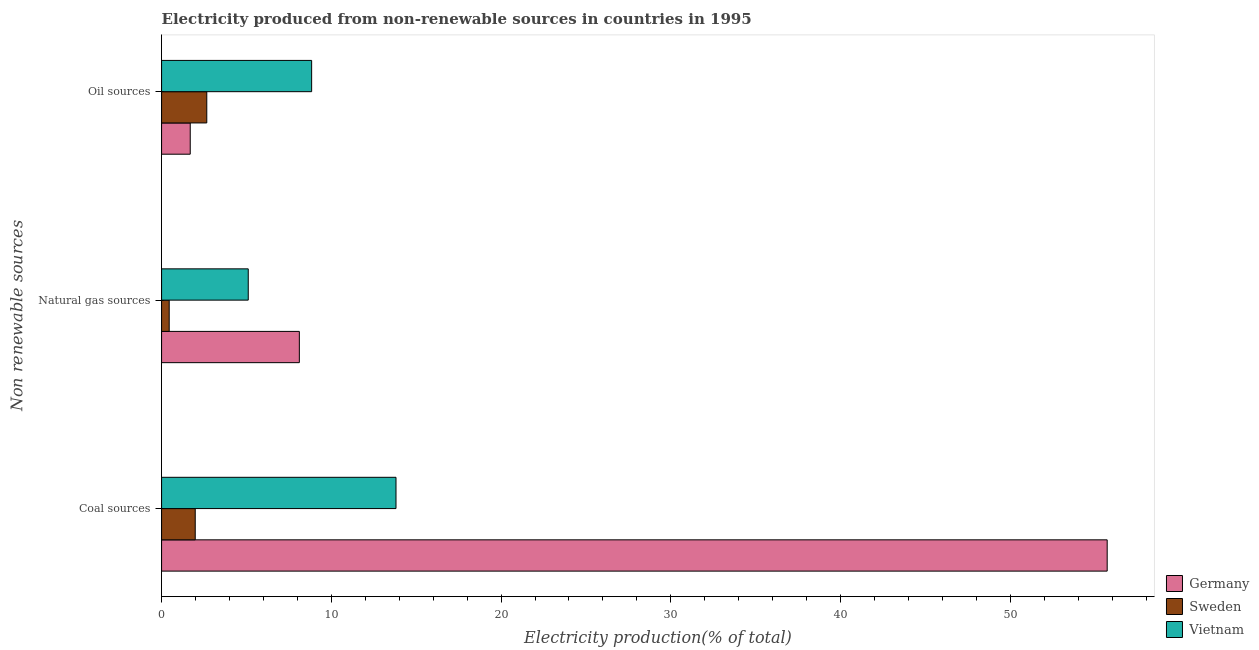How many different coloured bars are there?
Provide a short and direct response. 3. How many groups of bars are there?
Offer a terse response. 3. Are the number of bars per tick equal to the number of legend labels?
Give a very brief answer. Yes. What is the label of the 2nd group of bars from the top?
Offer a terse response. Natural gas sources. What is the percentage of electricity produced by natural gas in Germany?
Provide a short and direct response. 8.12. Across all countries, what is the maximum percentage of electricity produced by coal?
Your answer should be compact. 55.71. Across all countries, what is the minimum percentage of electricity produced by coal?
Your answer should be compact. 1.98. In which country was the percentage of electricity produced by natural gas minimum?
Make the answer very short. Sweden. What is the total percentage of electricity produced by natural gas in the graph?
Your answer should be very brief. 13.67. What is the difference between the percentage of electricity produced by oil sources in Sweden and that in Vietnam?
Ensure brevity in your answer.  -6.18. What is the difference between the percentage of electricity produced by natural gas in Germany and the percentage of electricity produced by oil sources in Sweden?
Your response must be concise. 5.45. What is the average percentage of electricity produced by natural gas per country?
Provide a short and direct response. 4.56. What is the difference between the percentage of electricity produced by coal and percentage of electricity produced by natural gas in Sweden?
Give a very brief answer. 1.53. In how many countries, is the percentage of electricity produced by coal greater than 4 %?
Give a very brief answer. 2. What is the ratio of the percentage of electricity produced by natural gas in Vietnam to that in Germany?
Your response must be concise. 0.63. Is the percentage of electricity produced by coal in Germany less than that in Vietnam?
Make the answer very short. No. Is the difference between the percentage of electricity produced by coal in Sweden and Germany greater than the difference between the percentage of electricity produced by oil sources in Sweden and Germany?
Provide a succinct answer. No. What is the difference between the highest and the second highest percentage of electricity produced by coal?
Your answer should be compact. 41.9. What is the difference between the highest and the lowest percentage of electricity produced by coal?
Your response must be concise. 53.72. Is it the case that in every country, the sum of the percentage of electricity produced by coal and percentage of electricity produced by natural gas is greater than the percentage of electricity produced by oil sources?
Your answer should be very brief. No. How many bars are there?
Your response must be concise. 9. Are all the bars in the graph horizontal?
Your response must be concise. Yes. How many countries are there in the graph?
Give a very brief answer. 3. Are the values on the major ticks of X-axis written in scientific E-notation?
Keep it short and to the point. No. Does the graph contain grids?
Give a very brief answer. No. Where does the legend appear in the graph?
Make the answer very short. Bottom right. How are the legend labels stacked?
Your response must be concise. Vertical. What is the title of the graph?
Your answer should be compact. Electricity produced from non-renewable sources in countries in 1995. What is the label or title of the X-axis?
Make the answer very short. Electricity production(% of total). What is the label or title of the Y-axis?
Give a very brief answer. Non renewable sources. What is the Electricity production(% of total) of Germany in Coal sources?
Ensure brevity in your answer.  55.71. What is the Electricity production(% of total) in Sweden in Coal sources?
Your answer should be compact. 1.98. What is the Electricity production(% of total) in Vietnam in Coal sources?
Keep it short and to the point. 13.81. What is the Electricity production(% of total) of Germany in Natural gas sources?
Your answer should be very brief. 8.12. What is the Electricity production(% of total) in Sweden in Natural gas sources?
Keep it short and to the point. 0.45. What is the Electricity production(% of total) in Vietnam in Natural gas sources?
Offer a very short reply. 5.11. What is the Electricity production(% of total) of Germany in Oil sources?
Provide a succinct answer. 1.69. What is the Electricity production(% of total) in Sweden in Oil sources?
Keep it short and to the point. 2.66. What is the Electricity production(% of total) of Vietnam in Oil sources?
Provide a succinct answer. 8.84. Across all Non renewable sources, what is the maximum Electricity production(% of total) of Germany?
Provide a succinct answer. 55.71. Across all Non renewable sources, what is the maximum Electricity production(% of total) of Sweden?
Keep it short and to the point. 2.66. Across all Non renewable sources, what is the maximum Electricity production(% of total) in Vietnam?
Provide a succinct answer. 13.81. Across all Non renewable sources, what is the minimum Electricity production(% of total) in Germany?
Provide a succinct answer. 1.69. Across all Non renewable sources, what is the minimum Electricity production(% of total) of Sweden?
Give a very brief answer. 0.45. Across all Non renewable sources, what is the minimum Electricity production(% of total) of Vietnam?
Make the answer very short. 5.11. What is the total Electricity production(% of total) in Germany in the graph?
Offer a terse response. 65.51. What is the total Electricity production(% of total) in Sweden in the graph?
Your answer should be compact. 5.1. What is the total Electricity production(% of total) of Vietnam in the graph?
Ensure brevity in your answer.  27.76. What is the difference between the Electricity production(% of total) of Germany in Coal sources and that in Natural gas sources?
Give a very brief answer. 47.59. What is the difference between the Electricity production(% of total) in Sweden in Coal sources and that in Natural gas sources?
Your answer should be compact. 1.53. What is the difference between the Electricity production(% of total) in Vietnam in Coal sources and that in Natural gas sources?
Offer a very short reply. 8.7. What is the difference between the Electricity production(% of total) of Germany in Coal sources and that in Oil sources?
Give a very brief answer. 54.02. What is the difference between the Electricity production(% of total) in Sweden in Coal sources and that in Oil sources?
Your response must be concise. -0.68. What is the difference between the Electricity production(% of total) of Vietnam in Coal sources and that in Oil sources?
Your response must be concise. 4.97. What is the difference between the Electricity production(% of total) of Germany in Natural gas sources and that in Oil sources?
Make the answer very short. 6.43. What is the difference between the Electricity production(% of total) in Sweden in Natural gas sources and that in Oil sources?
Your answer should be compact. -2.21. What is the difference between the Electricity production(% of total) in Vietnam in Natural gas sources and that in Oil sources?
Provide a short and direct response. -3.73. What is the difference between the Electricity production(% of total) of Germany in Coal sources and the Electricity production(% of total) of Sweden in Natural gas sources?
Your answer should be very brief. 55.26. What is the difference between the Electricity production(% of total) of Germany in Coal sources and the Electricity production(% of total) of Vietnam in Natural gas sources?
Offer a very short reply. 50.6. What is the difference between the Electricity production(% of total) in Sweden in Coal sources and the Electricity production(% of total) in Vietnam in Natural gas sources?
Give a very brief answer. -3.12. What is the difference between the Electricity production(% of total) in Germany in Coal sources and the Electricity production(% of total) in Sweden in Oil sources?
Provide a succinct answer. 53.04. What is the difference between the Electricity production(% of total) of Germany in Coal sources and the Electricity production(% of total) of Vietnam in Oil sources?
Ensure brevity in your answer.  46.87. What is the difference between the Electricity production(% of total) of Sweden in Coal sources and the Electricity production(% of total) of Vietnam in Oil sources?
Offer a terse response. -6.86. What is the difference between the Electricity production(% of total) of Germany in Natural gas sources and the Electricity production(% of total) of Sweden in Oil sources?
Make the answer very short. 5.45. What is the difference between the Electricity production(% of total) in Germany in Natural gas sources and the Electricity production(% of total) in Vietnam in Oil sources?
Make the answer very short. -0.72. What is the difference between the Electricity production(% of total) of Sweden in Natural gas sources and the Electricity production(% of total) of Vietnam in Oil sources?
Provide a short and direct response. -8.39. What is the average Electricity production(% of total) of Germany per Non renewable sources?
Your answer should be very brief. 21.84. What is the average Electricity production(% of total) in Sweden per Non renewable sources?
Keep it short and to the point. 1.7. What is the average Electricity production(% of total) of Vietnam per Non renewable sources?
Offer a terse response. 9.25. What is the difference between the Electricity production(% of total) in Germany and Electricity production(% of total) in Sweden in Coal sources?
Offer a terse response. 53.72. What is the difference between the Electricity production(% of total) of Germany and Electricity production(% of total) of Vietnam in Coal sources?
Provide a short and direct response. 41.9. What is the difference between the Electricity production(% of total) of Sweden and Electricity production(% of total) of Vietnam in Coal sources?
Your answer should be compact. -11.83. What is the difference between the Electricity production(% of total) in Germany and Electricity production(% of total) in Sweden in Natural gas sources?
Your response must be concise. 7.67. What is the difference between the Electricity production(% of total) of Germany and Electricity production(% of total) of Vietnam in Natural gas sources?
Make the answer very short. 3.01. What is the difference between the Electricity production(% of total) of Sweden and Electricity production(% of total) of Vietnam in Natural gas sources?
Your response must be concise. -4.66. What is the difference between the Electricity production(% of total) in Germany and Electricity production(% of total) in Sweden in Oil sources?
Your answer should be compact. -0.97. What is the difference between the Electricity production(% of total) of Germany and Electricity production(% of total) of Vietnam in Oil sources?
Ensure brevity in your answer.  -7.15. What is the difference between the Electricity production(% of total) of Sweden and Electricity production(% of total) of Vietnam in Oil sources?
Your response must be concise. -6.18. What is the ratio of the Electricity production(% of total) of Germany in Coal sources to that in Natural gas sources?
Give a very brief answer. 6.86. What is the ratio of the Electricity production(% of total) in Sweden in Coal sources to that in Natural gas sources?
Your answer should be very brief. 4.41. What is the ratio of the Electricity production(% of total) in Vietnam in Coal sources to that in Natural gas sources?
Make the answer very short. 2.7. What is the ratio of the Electricity production(% of total) in Germany in Coal sources to that in Oil sources?
Make the answer very short. 32.99. What is the ratio of the Electricity production(% of total) of Sweden in Coal sources to that in Oil sources?
Make the answer very short. 0.74. What is the ratio of the Electricity production(% of total) in Vietnam in Coal sources to that in Oil sources?
Make the answer very short. 1.56. What is the ratio of the Electricity production(% of total) in Germany in Natural gas sources to that in Oil sources?
Give a very brief answer. 4.81. What is the ratio of the Electricity production(% of total) in Sweden in Natural gas sources to that in Oil sources?
Give a very brief answer. 0.17. What is the ratio of the Electricity production(% of total) in Vietnam in Natural gas sources to that in Oil sources?
Offer a very short reply. 0.58. What is the difference between the highest and the second highest Electricity production(% of total) of Germany?
Give a very brief answer. 47.59. What is the difference between the highest and the second highest Electricity production(% of total) of Sweden?
Offer a terse response. 0.68. What is the difference between the highest and the second highest Electricity production(% of total) of Vietnam?
Provide a short and direct response. 4.97. What is the difference between the highest and the lowest Electricity production(% of total) of Germany?
Keep it short and to the point. 54.02. What is the difference between the highest and the lowest Electricity production(% of total) in Sweden?
Provide a succinct answer. 2.21. What is the difference between the highest and the lowest Electricity production(% of total) of Vietnam?
Your answer should be compact. 8.7. 